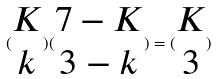Convert formula to latex. <formula><loc_0><loc_0><loc_500><loc_500>( \begin{matrix} K \\ k \end{matrix} ) ( \begin{matrix} 7 - K \\ 3 - k \end{matrix} ) = ( \begin{matrix} K \\ 3 \end{matrix} )</formula> 